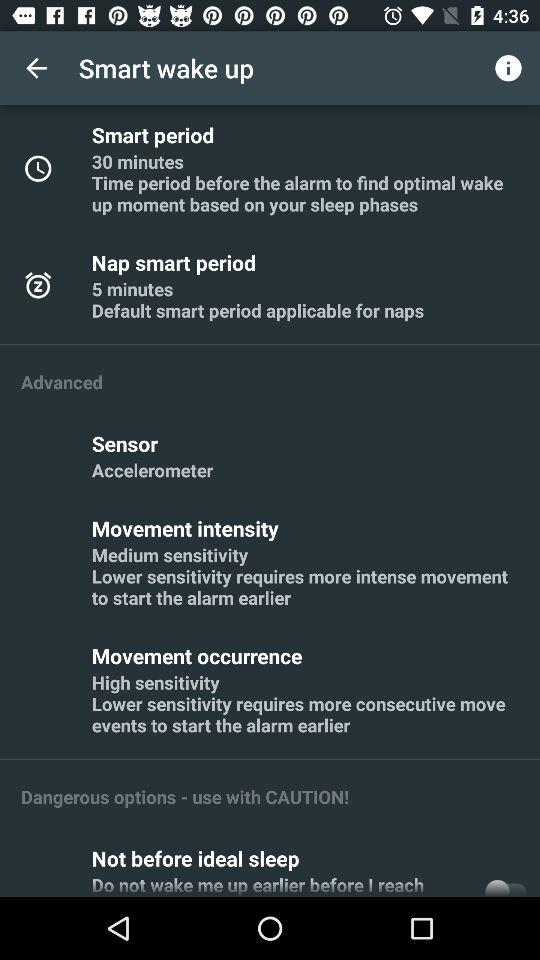What is the status of "Not before ideal sleep"? The status is "off". 